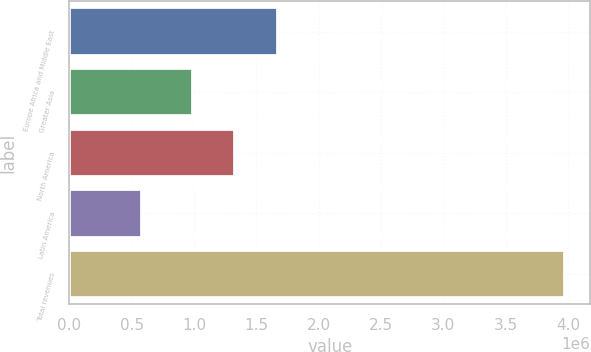Convert chart to OTSL. <chart><loc_0><loc_0><loc_500><loc_500><bar_chart><fcel>Europe Africa and Middle East<fcel>Greater Asia<fcel>North America<fcel>Latin America<fcel>Total revenues<nl><fcel>1.67051e+06<fcel>991015<fcel>1.33076e+06<fcel>580083<fcel>3.97754e+06<nl></chart> 